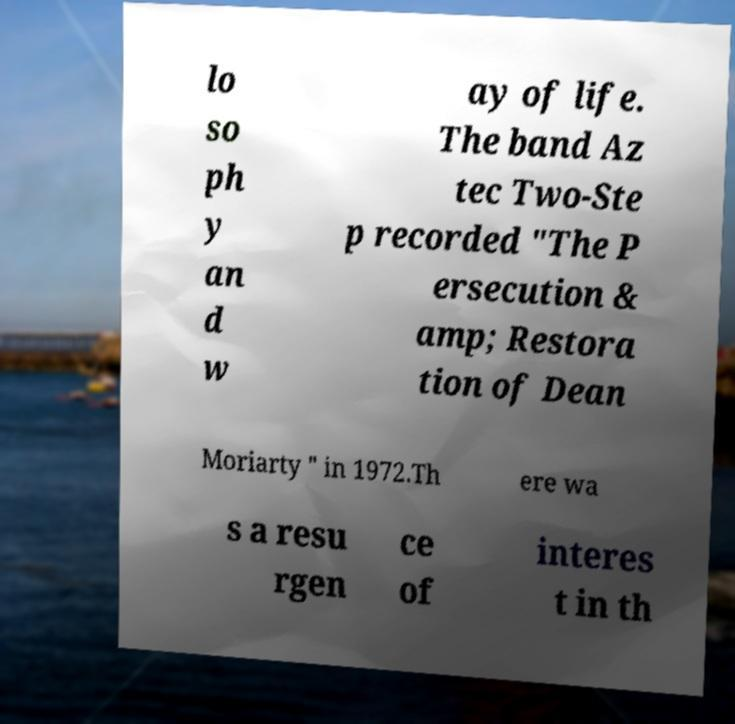There's text embedded in this image that I need extracted. Can you transcribe it verbatim? lo so ph y an d w ay of life. The band Az tec Two-Ste p recorded "The P ersecution & amp; Restora tion of Dean Moriarty " in 1972.Th ere wa s a resu rgen ce of interes t in th 